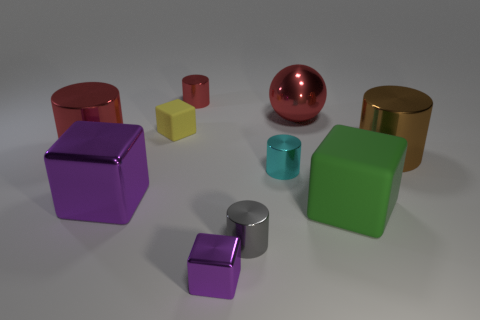What materials do the objects in the image seem to be made of? The objects in the image appear to be made of various metals, with a shiny, reflective surface that suggests they could be aluminum, steel, or perhaps even painted plastic with a metallic finish to simulate the appearance of metal. 